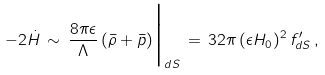<formula> <loc_0><loc_0><loc_500><loc_500>- 2 { \dot { H } } \, \sim \, \frac { 8 \pi \epsilon } { \Lambda } \, ( { \bar { \rho } } + { \bar { p } } ) \Big | _ { d S } \, = \, 3 2 \pi \, ( \epsilon H _ { 0 } ) ^ { 2 } \, f ^ { \prime } _ { d S } \, ,</formula> 